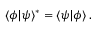<formula> <loc_0><loc_0><loc_500><loc_500>\langle \phi | \psi \rangle ^ { * } = \langle \psi | \phi \rangle \, .</formula> 